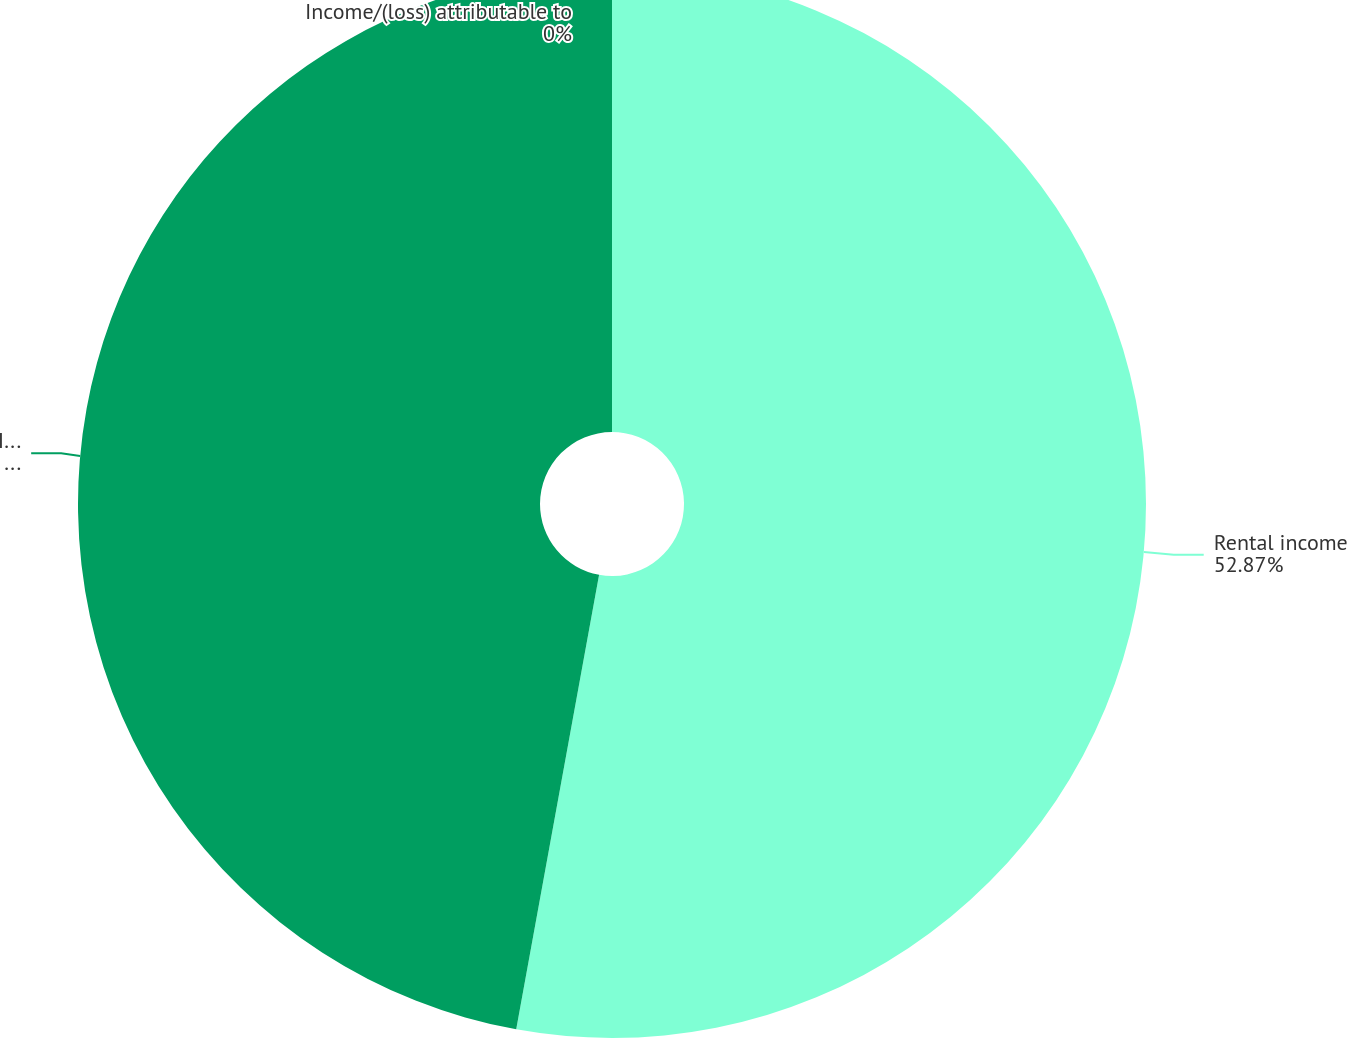Convert chart. <chart><loc_0><loc_0><loc_500><loc_500><pie_chart><fcel>Rental income<fcel>Income/(loss)<fcel>Income/(loss) attributable to<nl><fcel>52.87%<fcel>47.13%<fcel>0.0%<nl></chart> 